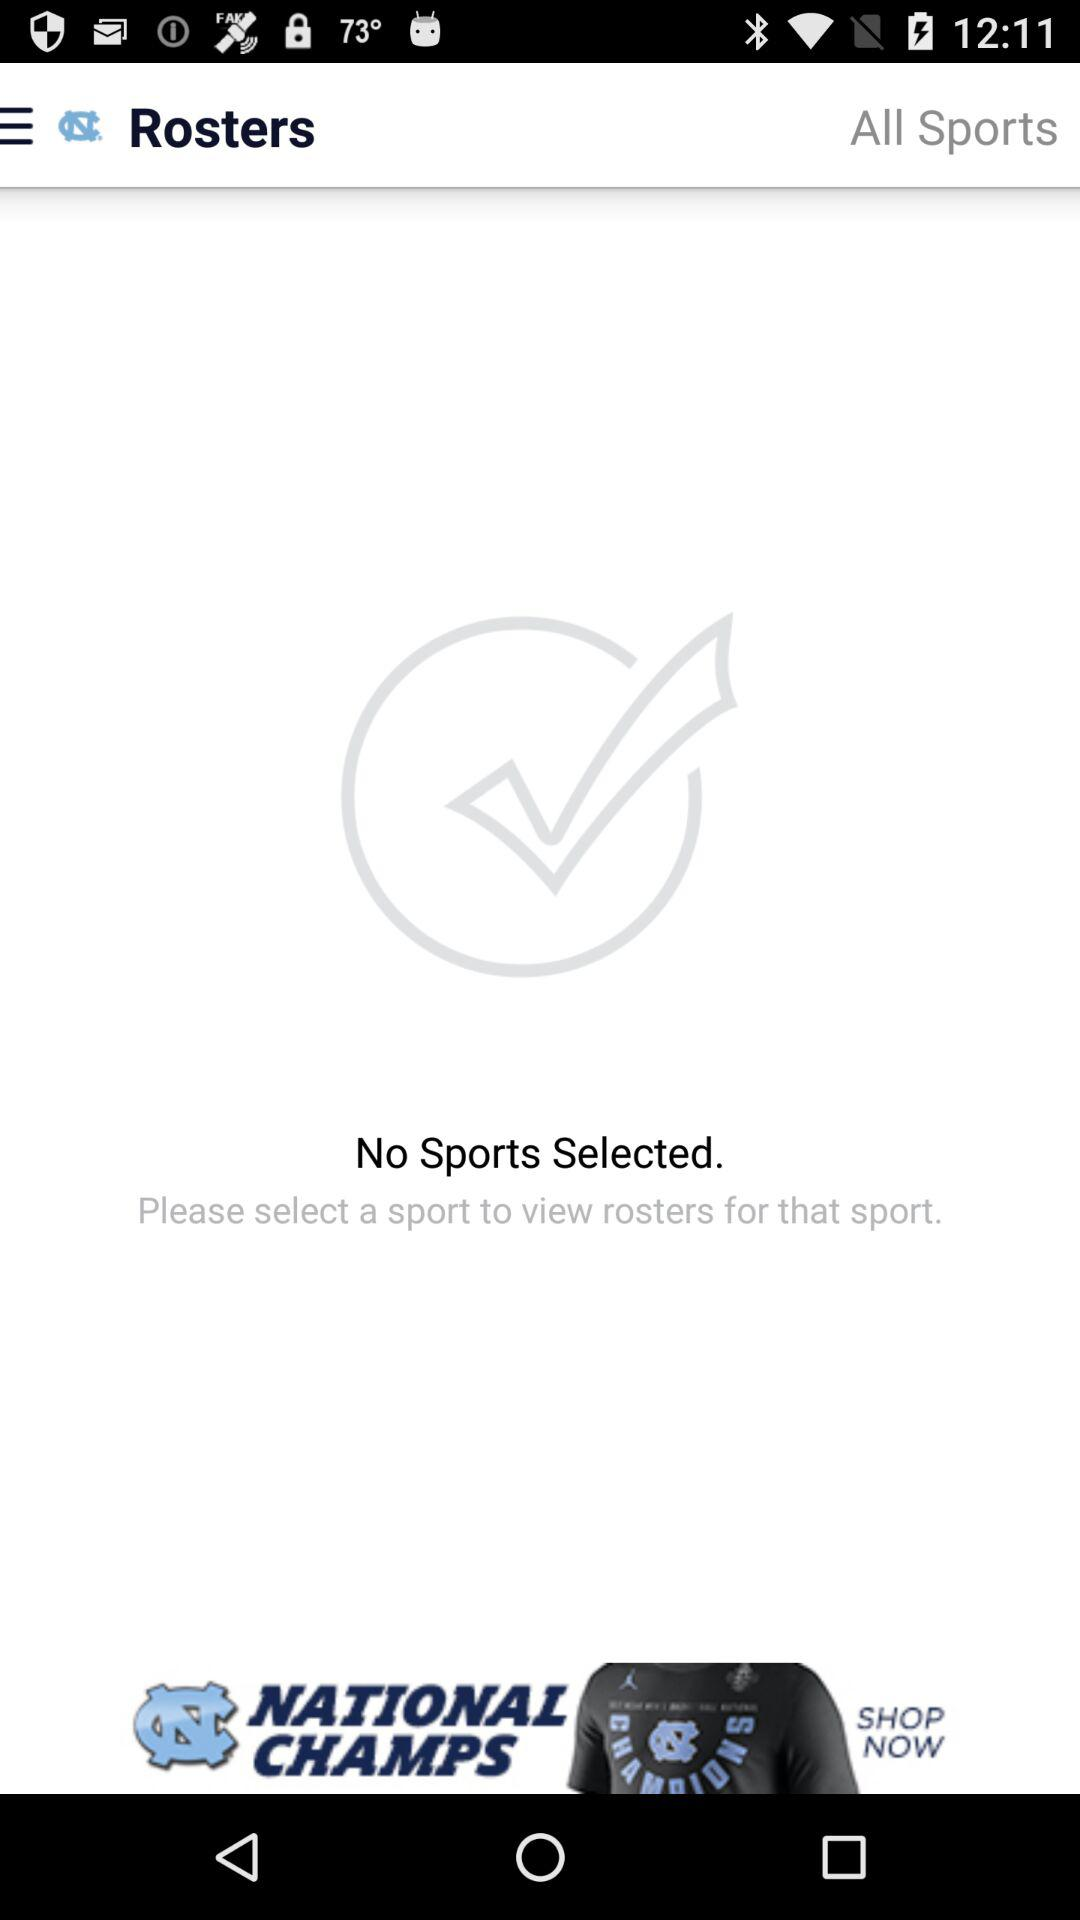Were there any sports selected? There were no sports selected. 